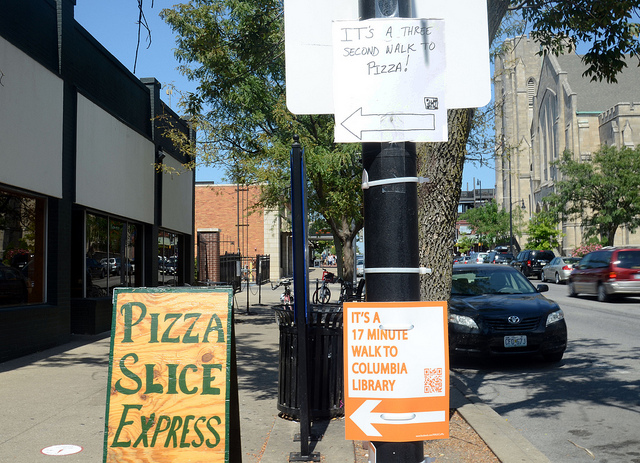Is there any cultural or historical significance visible in this image? The image shows a street view that includes what appears to be a large stone building in the background, which could have historical significance. The architectural style and the substantial size indicate it might be an older structure, possibly a landmark. The street itself exhibits a blend of modern signage with this older architecture, hinting at a neighborhood that has grown and adapted over time while still retaining elements of its historical roots. 